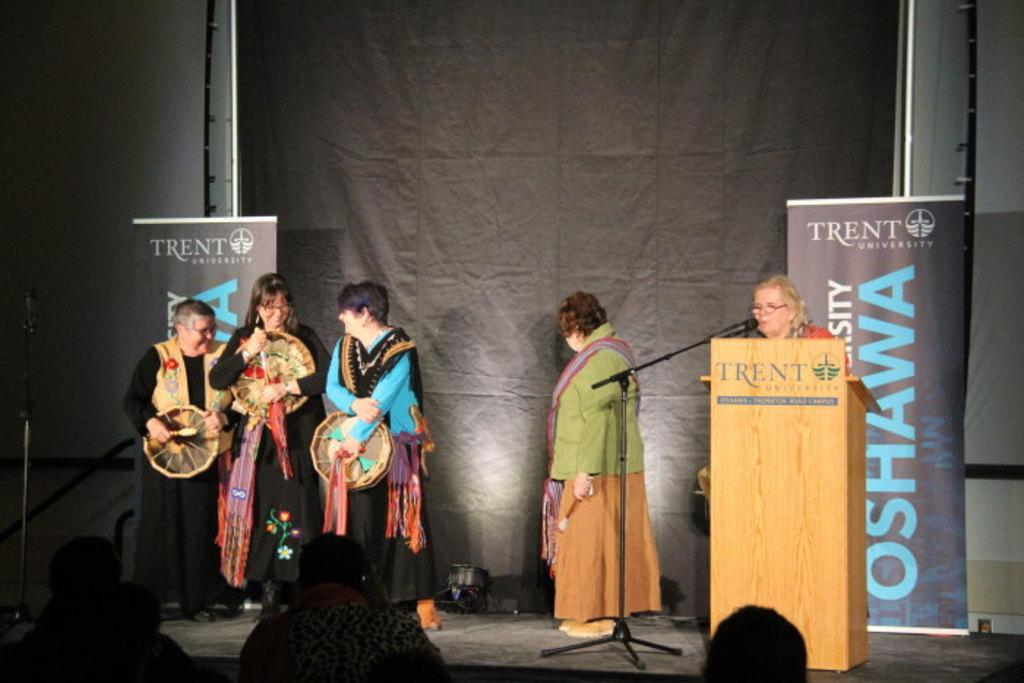How many people are in the image? There is a group of people in the image. Where are some of the people located in the image? Some people are standing on a stage. What is the woman at the front doing? The woman is standing at a podium and talking on a microphone. What can be seen in the background of the image? There is a banner visible in the background. What type of bean is being used as a prop by the woman at the podium? There is no bean present in the image; the woman is using a microphone to speak. 